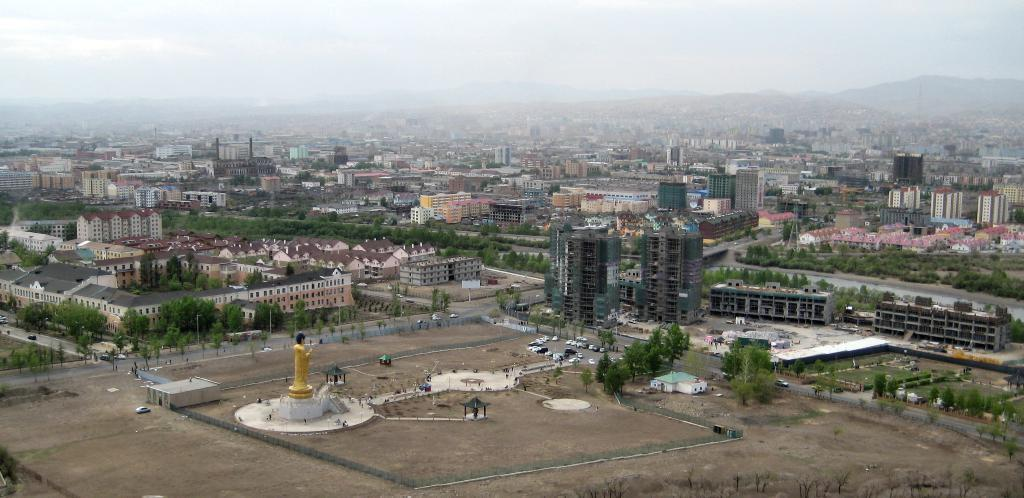What type of location is depicted in the image? The image is of a city. What can be seen moving on the roads in the image? There are vehicles in the image. What do the roads connect in the image? The roads connect various parts of the city in the image. What structures are present in the image? There are buildings in the image. What type of vegetation can be seen in the image? There are trees in the image. What type of landmark is present in the image? There is a statue in the image. What type of natural feature can be seen in the image? There are hills in the image. What is visible in the background of the image? The sky is visible in the background of the image. How many boats are sailing on the hills in the image? There are no boats present in the image, as it depicts a city with hills and not a body of water. 